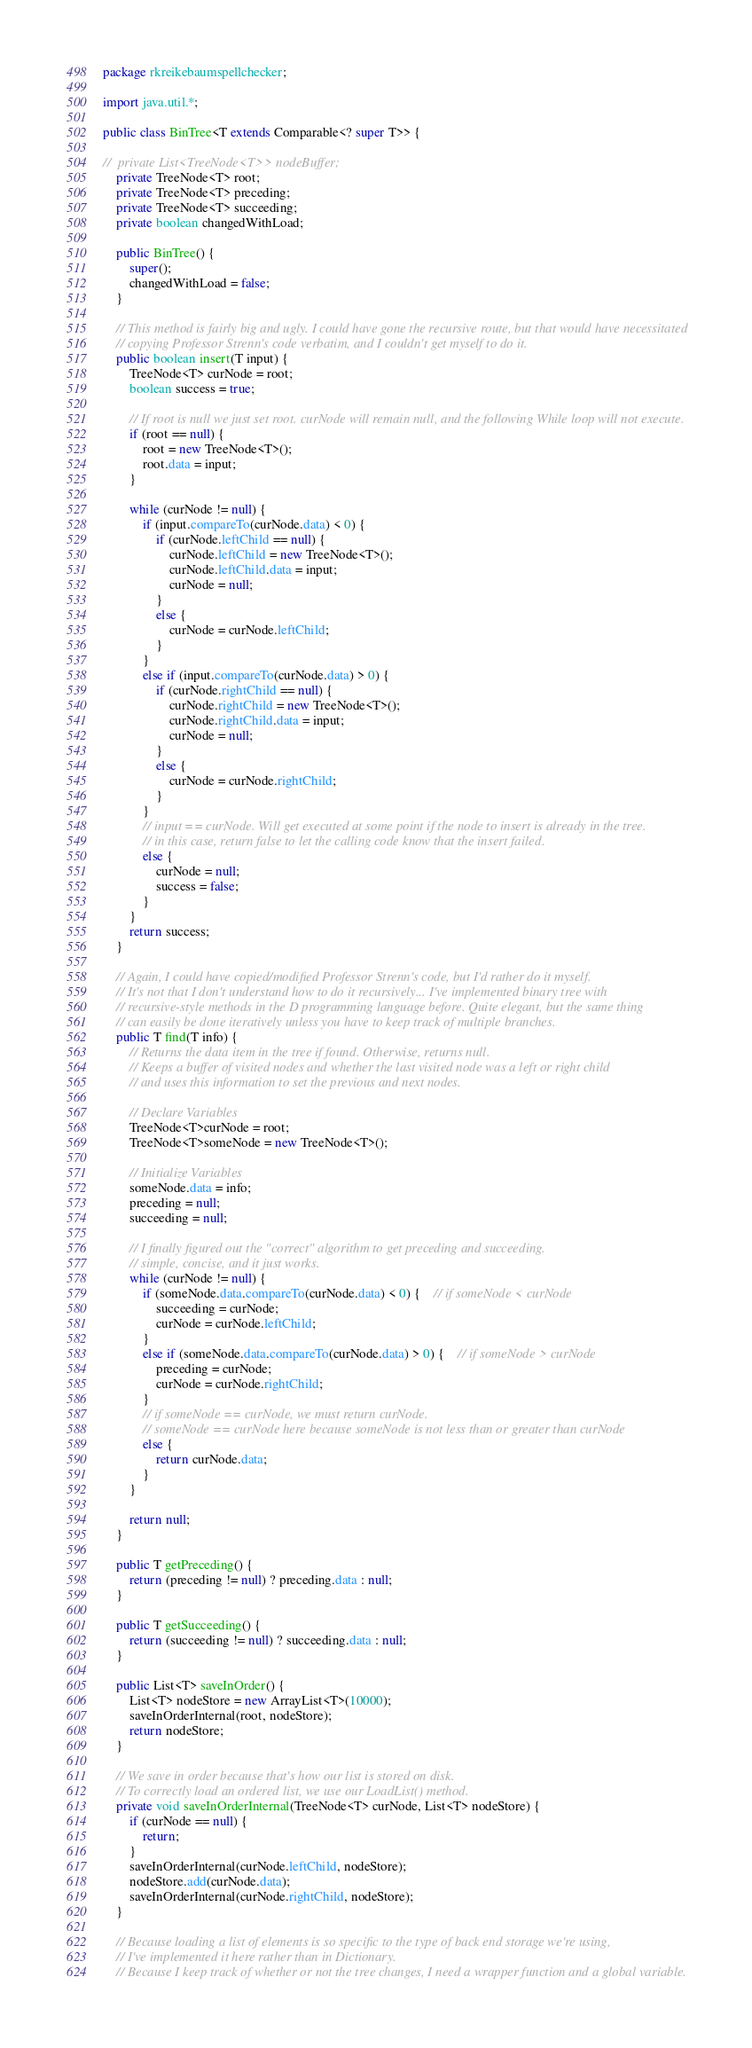Convert code to text. <code><loc_0><loc_0><loc_500><loc_500><_Java_>package rkreikebaumspellchecker;

import java.util.*;

public class BinTree<T extends Comparable<? super T>> {
	
//	private List<TreeNode<T>> nodeBuffer;
	private TreeNode<T> root;
	private TreeNode<T> preceding;
	private TreeNode<T> succeeding;
	private boolean changedWithLoad;

	public BinTree() {
		super();
		changedWithLoad = false;
	}
	
	// This method is fairly big and ugly. I could have gone the recursive route, but that would have necessitated
	// copying Professor Strenn's code verbatim, and I couldn't get myself to do it.
	public boolean insert(T input) {
		TreeNode<T> curNode = root;
		boolean success = true;
		
		// If root is null we just set root. curNode will remain null, and the following While loop will not execute.
		if (root == null) {
			root = new TreeNode<T>();
			root.data = input;
		}
		
		while (curNode != null) {
			if (input.compareTo(curNode.data) < 0) {
				if (curNode.leftChild == null) {
					curNode.leftChild = new TreeNode<T>();
					curNode.leftChild.data = input;
					curNode = null;
				}
				else {
					curNode = curNode.leftChild;
				}
			}
			else if (input.compareTo(curNode.data) > 0) {
				if (curNode.rightChild == null) {
					curNode.rightChild = new TreeNode<T>();
					curNode.rightChild.data = input;
					curNode = null;
				}
				else {
					curNode = curNode.rightChild;
				}
			}
			// input == curNode. Will get executed at some point if the node to insert is already in the tree.
			// in this case, return false to let the calling code know that the insert failed.
			else {
				curNode = null;
				success = false;
			}
		}
		return success;
	}
	
	// Again, I could have copied/modified Professor Strenn's code, but I'd rather do it myself.
	// It's not that I don't understand how to do it recursively... I've implemented binary tree with
	// recursive-style methods in the D programming language before. Quite elegant, but the same thing
	// can easily be done iteratively unless you have to keep track of multiple branches.
	public T find(T info) {
		// Returns the data item in the tree if found. Otherwise, returns null.
		// Keeps a buffer of visited nodes and whether the last visited node was a left or right child
		// and uses this information to set the previous and next nodes.
		
		// Declare Variables
		TreeNode<T>curNode = root;
		TreeNode<T>someNode = new TreeNode<T>();

		// Initialize Variables
		someNode.data = info;
		preceding = null;
		succeeding = null;
		
		// I finally figured out the "correct" algorithm to get preceding and succeeding.
		// simple, concise, and it just works.
		while (curNode != null) {
			if (someNode.data.compareTo(curNode.data) < 0) {	// if someNode < curNode
				succeeding = curNode;
				curNode = curNode.leftChild;
			}
			else if (someNode.data.compareTo(curNode.data) > 0) {	// if someNode > curNode
				preceding = curNode;
				curNode = curNode.rightChild;
			}
			// if someNode == curNode, we must return curNode. 
			// someNode == curNode here because someNode is not less than or greater than curNode
			else {
				return curNode.data;
			}
		}
		
		return null;
	}

	public T getPreceding() {
		return (preceding != null) ? preceding.data : null;
	}

	public T getSucceeding() {
		return (succeeding != null) ? succeeding.data : null;
	}

	public List<T> saveInOrder() {
		List<T> nodeStore = new ArrayList<T>(10000);
		saveInOrderInternal(root, nodeStore);
		return nodeStore;
	}

	// We save in order because that's how our list is stored on disk.
	// To correctly load an ordered list, we use our LoadList() method.
	private void saveInOrderInternal(TreeNode<T> curNode, List<T> nodeStore) {
		if (curNode == null) {
			return;
		}
		saveInOrderInternal(curNode.leftChild, nodeStore);
		nodeStore.add(curNode.data);
		saveInOrderInternal(curNode.rightChild, nodeStore);
	}
	
	// Because loading a list of elements is so specific to the type of back end storage we're using,
	// I've implemented it here rather than in Dictionary.
	// Because I keep track of whether or not the tree changes, I need a wrapper function and a global variable.</code> 